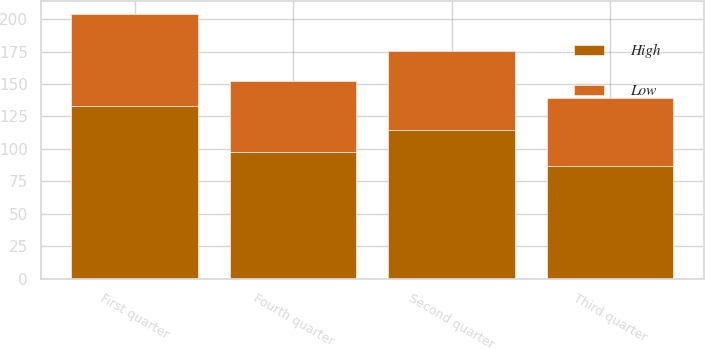Convert chart to OTSL. <chart><loc_0><loc_0><loc_500><loc_500><stacked_bar_chart><ecel><fcel>First quarter<fcel>Second quarter<fcel>Third quarter<fcel>Fourth quarter<nl><fcel>High<fcel>133.43<fcel>114.8<fcel>86.65<fcel>97.8<nl><fcel>Low<fcel>70.13<fcel>60.7<fcel>52.81<fcel>54.34<nl></chart> 